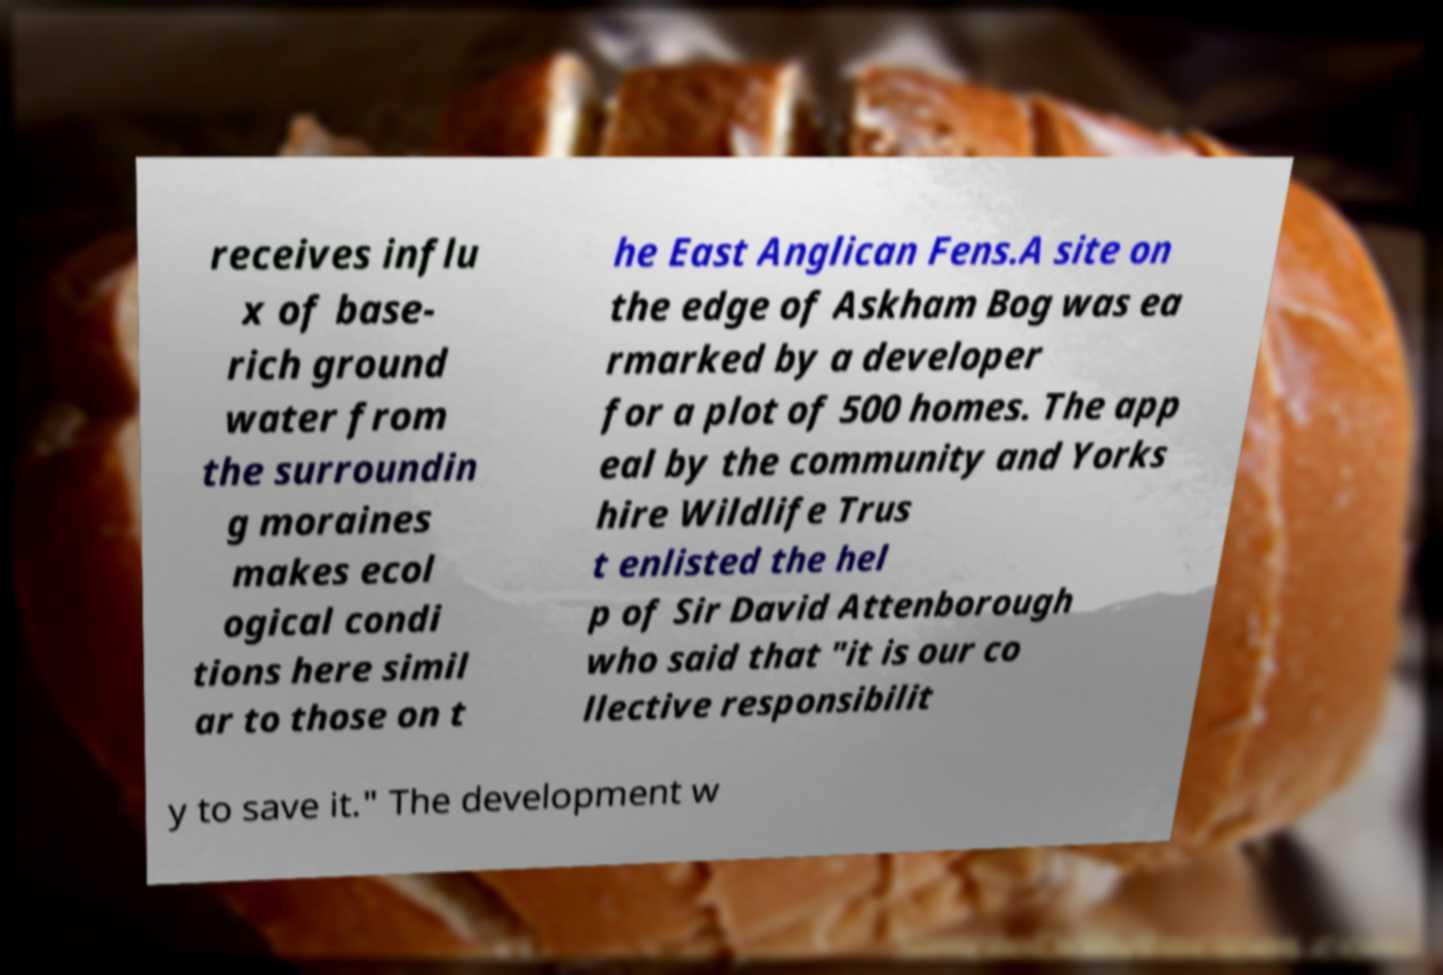There's text embedded in this image that I need extracted. Can you transcribe it verbatim? receives influ x of base- rich ground water from the surroundin g moraines makes ecol ogical condi tions here simil ar to those on t he East Anglican Fens.A site on the edge of Askham Bog was ea rmarked by a developer for a plot of 500 homes. The app eal by the community and Yorks hire Wildlife Trus t enlisted the hel p of Sir David Attenborough who said that "it is our co llective responsibilit y to save it." The development w 